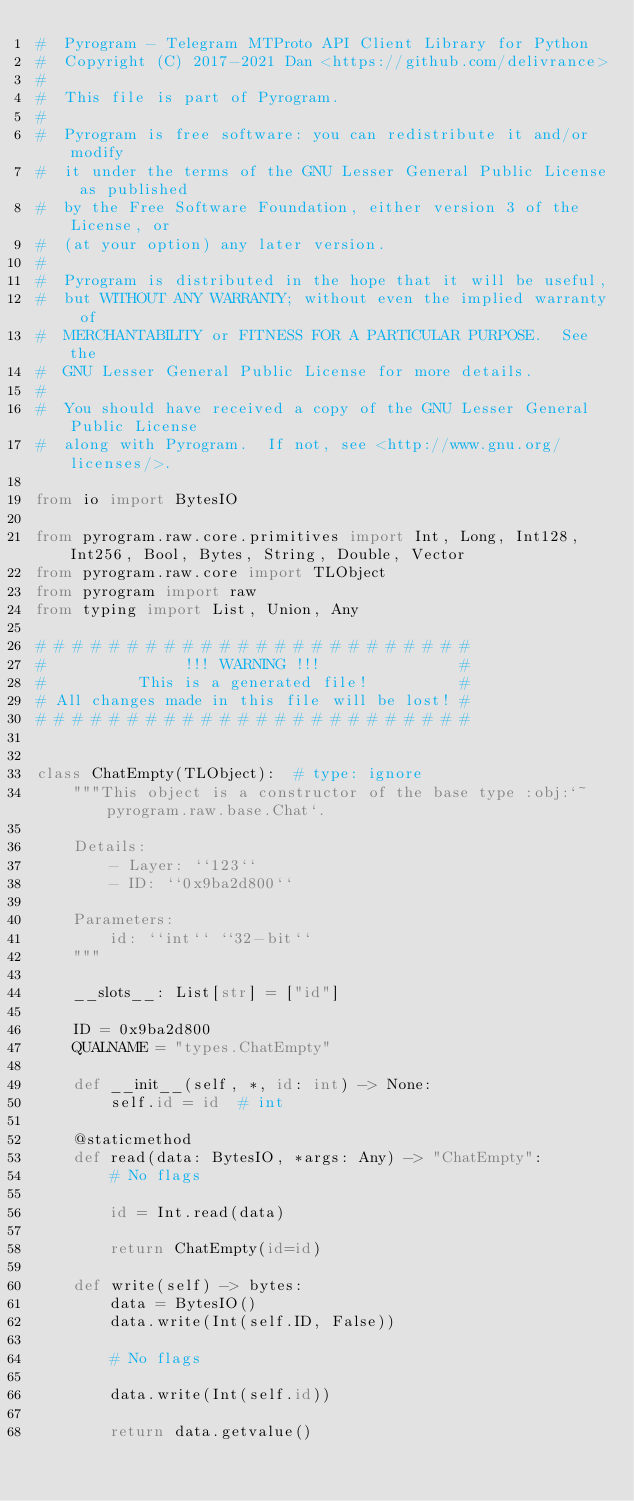Convert code to text. <code><loc_0><loc_0><loc_500><loc_500><_Python_>#  Pyrogram - Telegram MTProto API Client Library for Python
#  Copyright (C) 2017-2021 Dan <https://github.com/delivrance>
#
#  This file is part of Pyrogram.
#
#  Pyrogram is free software: you can redistribute it and/or modify
#  it under the terms of the GNU Lesser General Public License as published
#  by the Free Software Foundation, either version 3 of the License, or
#  (at your option) any later version.
#
#  Pyrogram is distributed in the hope that it will be useful,
#  but WITHOUT ANY WARRANTY; without even the implied warranty of
#  MERCHANTABILITY or FITNESS FOR A PARTICULAR PURPOSE.  See the
#  GNU Lesser General Public License for more details.
#
#  You should have received a copy of the GNU Lesser General Public License
#  along with Pyrogram.  If not, see <http://www.gnu.org/licenses/>.

from io import BytesIO

from pyrogram.raw.core.primitives import Int, Long, Int128, Int256, Bool, Bytes, String, Double, Vector
from pyrogram.raw.core import TLObject
from pyrogram import raw
from typing import List, Union, Any

# # # # # # # # # # # # # # # # # # # # # # # #
#               !!! WARNING !!!               #
#          This is a generated file!          #
# All changes made in this file will be lost! #
# # # # # # # # # # # # # # # # # # # # # # # #


class ChatEmpty(TLObject):  # type: ignore
    """This object is a constructor of the base type :obj:`~pyrogram.raw.base.Chat`.

    Details:
        - Layer: ``123``
        - ID: ``0x9ba2d800``

    Parameters:
        id: ``int`` ``32-bit``
    """

    __slots__: List[str] = ["id"]

    ID = 0x9ba2d800
    QUALNAME = "types.ChatEmpty"

    def __init__(self, *, id: int) -> None:
        self.id = id  # int

    @staticmethod
    def read(data: BytesIO, *args: Any) -> "ChatEmpty":
        # No flags

        id = Int.read(data)

        return ChatEmpty(id=id)

    def write(self) -> bytes:
        data = BytesIO()
        data.write(Int(self.ID, False))

        # No flags

        data.write(Int(self.id))

        return data.getvalue()
</code> 